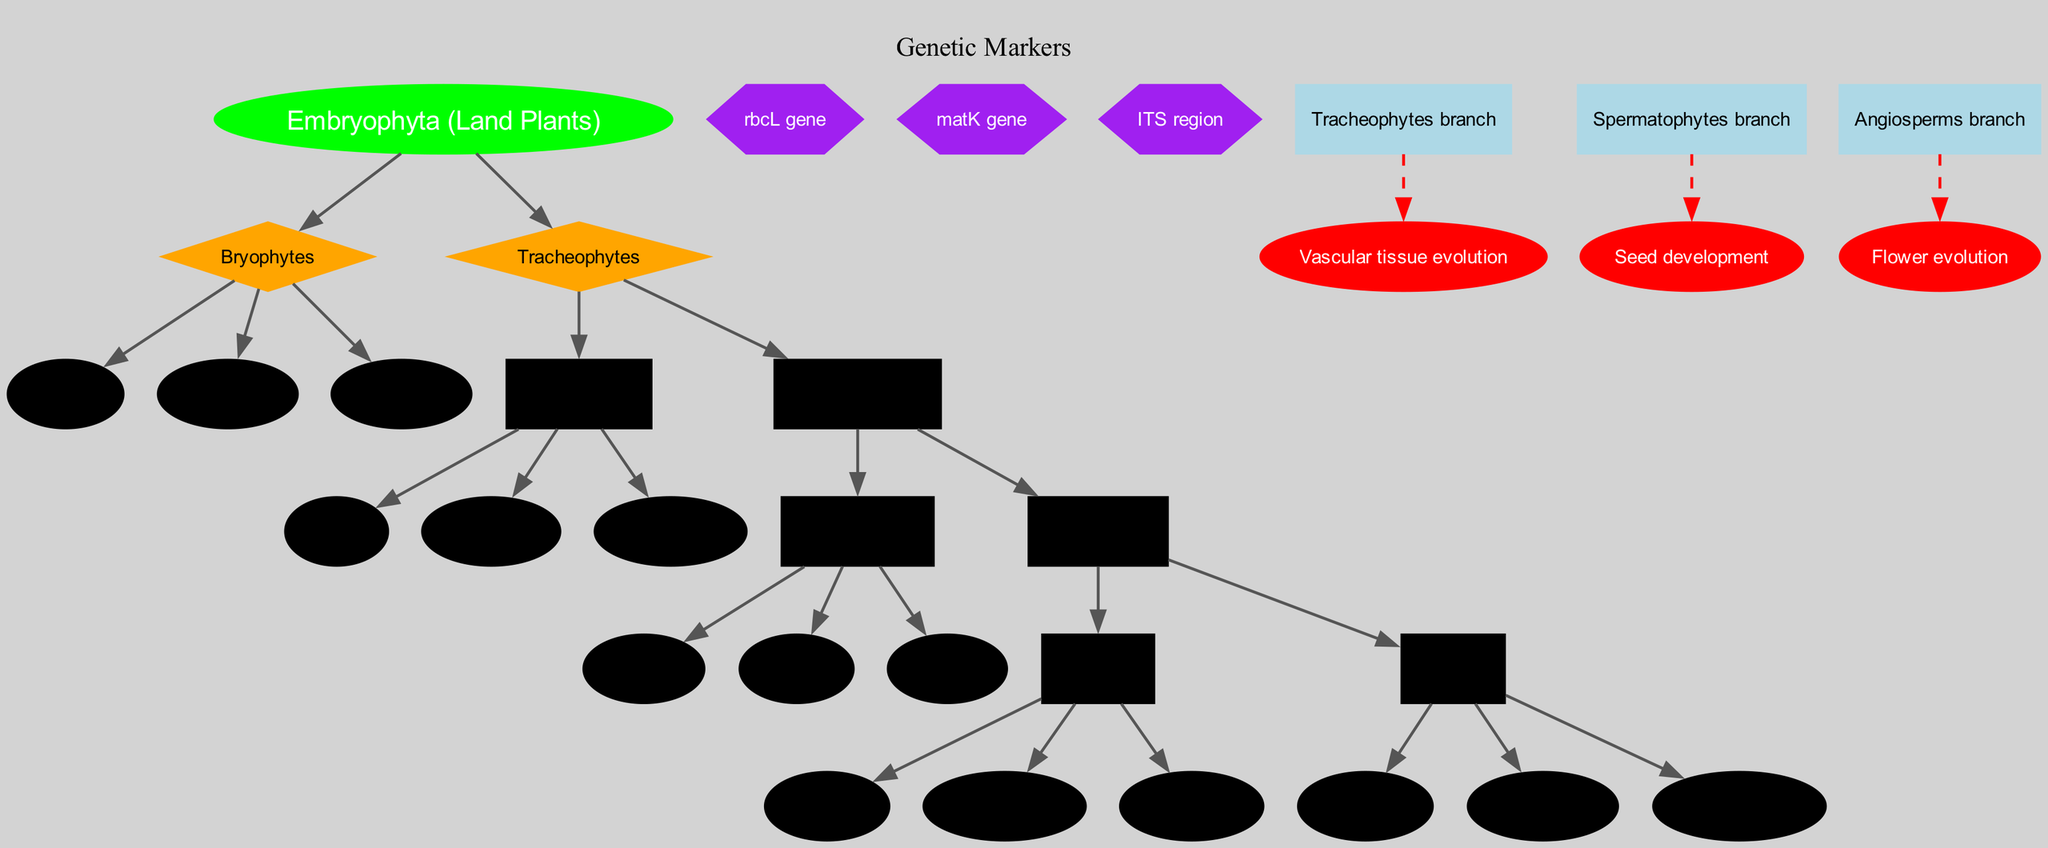What is the root of the phylogenetic tree? The root node in the diagram is labeled "Embryophyta (Land Plants)", which represents the most ancestral group in the phylogenetic tree.
Answer: Embryophyta (Land Plants) How many main branches are there? The diagram shows two main branches stemming from the root: "Bryophytes" and "Tracheophytes." Counting these, we find there are two main branches.
Answer: 2 What are the children of Tracheophytes? The "Tracheophytes" branch has two children: "Pteridophytes" and "Spermatophytes." There are no other children at this branch.
Answer: Pteridophytes and Spermatophytes Which evolutionary event is located at the Spermatophytes branch? The event that occurs at the "Spermatophytes" branch is "Seed development," which highlights a significant evolutionary change in this lineage.
Answer: Seed development Which genetic marker is listed in the diagram? Among the genetic markers mentioned in the diagram, "rbcL gene" is one of them. These markers are crucial for genetic analysis of diversity.
Answer: rbcL gene How are the children of Gymnosperms categorized? The Gymnosperms branch has three children: "Conifers," "Cycads," and "Ginkgos," showing the diversity within the gymnosperms group.
Answer: Conifers, Cycads, and Ginkgos What color is used for the evolutionary event "Flower evolution"? In the diagram, the evolutionary event "Flower evolution" is displayed in red, indicating its significance among evolutionary milestones.
Answer: Red What is the relationship between Angiosperms and Eudicots? "Angiosperms" is a parent branch of "Eudicots," meaning that Eudicots are a subgroup within the Angiosperms, showing a deeper evolutionary relationship.
Answer: Parent-Child relationship 